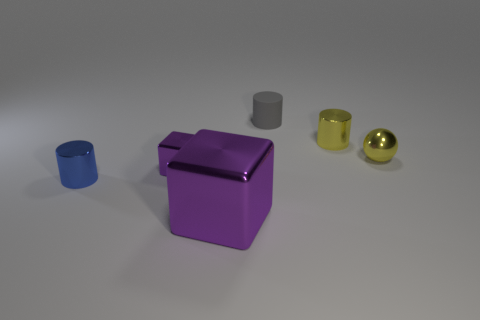There is a gray thing that is the same shape as the blue object; what material is it?
Give a very brief answer. Rubber. What material is the cylinder that is both to the left of the tiny yellow cylinder and behind the tiny blue cylinder?
Offer a terse response. Rubber. Is there any other thing that has the same color as the tiny cube?
Provide a short and direct response. Yes. Are there more big yellow rubber cylinders than yellow balls?
Your answer should be very brief. No. There is a thing that is on the right side of the small metal cylinder to the right of the matte object; how many small shiny cylinders are in front of it?
Keep it short and to the point. 1. There is a small gray rubber thing; what shape is it?
Offer a very short reply. Cylinder. How many other things are there of the same material as the small yellow cylinder?
Offer a very short reply. 4. Do the gray cylinder and the shiny sphere have the same size?
Ensure brevity in your answer.  Yes. The tiny blue metallic object to the left of the small matte thing has what shape?
Your answer should be compact. Cylinder. The shiny block in front of the shiny cylinder that is left of the gray rubber cylinder is what color?
Your response must be concise. Purple. 